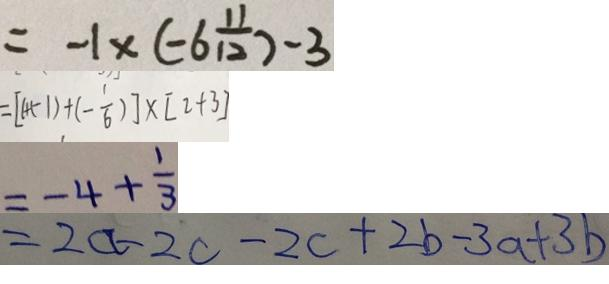Convert formula to latex. <formula><loc_0><loc_0><loc_500><loc_500>= - 1 \times ( - 6 \frac { 1 1 } { 1 2 } ) - 3 
 = [ 1 + ( - 1 ) + ( - \frac { 1 } { 6 } ) ] \times [ 2 + 3 ] 
 = - 4 + \frac { 1 } { 3 } 
 = 2 a - 2 c - 2 c + 2 b - 3 a + 3 b</formula> 